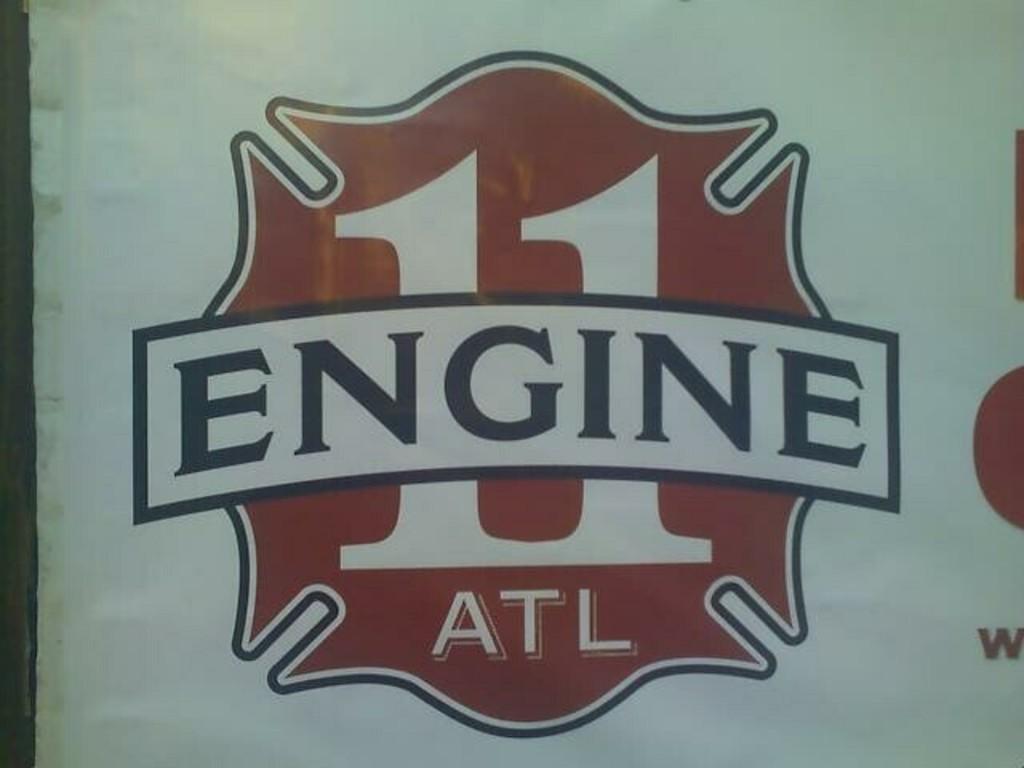What number is the engine?
Your answer should be compact. 11. What letters are under engine?
Your answer should be compact. Atl. 